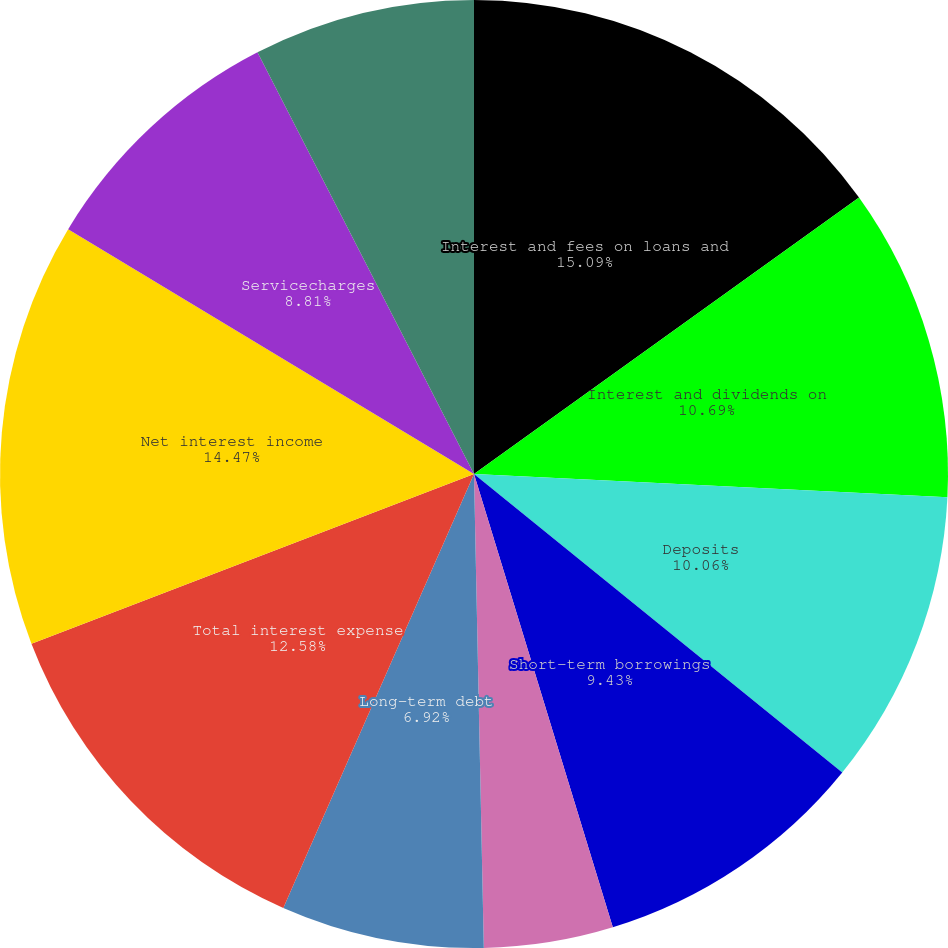Convert chart to OTSL. <chart><loc_0><loc_0><loc_500><loc_500><pie_chart><fcel>Interest and fees on loans and<fcel>Interest and dividends on<fcel>Deposits<fcel>Short-term borrowings<fcel>Trading account liabilities<fcel>Long-term debt<fcel>Total interest expense<fcel>Net interest income<fcel>Servicecharges<fcel>Investment and brokerage<nl><fcel>15.09%<fcel>10.69%<fcel>10.06%<fcel>9.43%<fcel>4.4%<fcel>6.92%<fcel>12.58%<fcel>14.47%<fcel>8.81%<fcel>7.55%<nl></chart> 